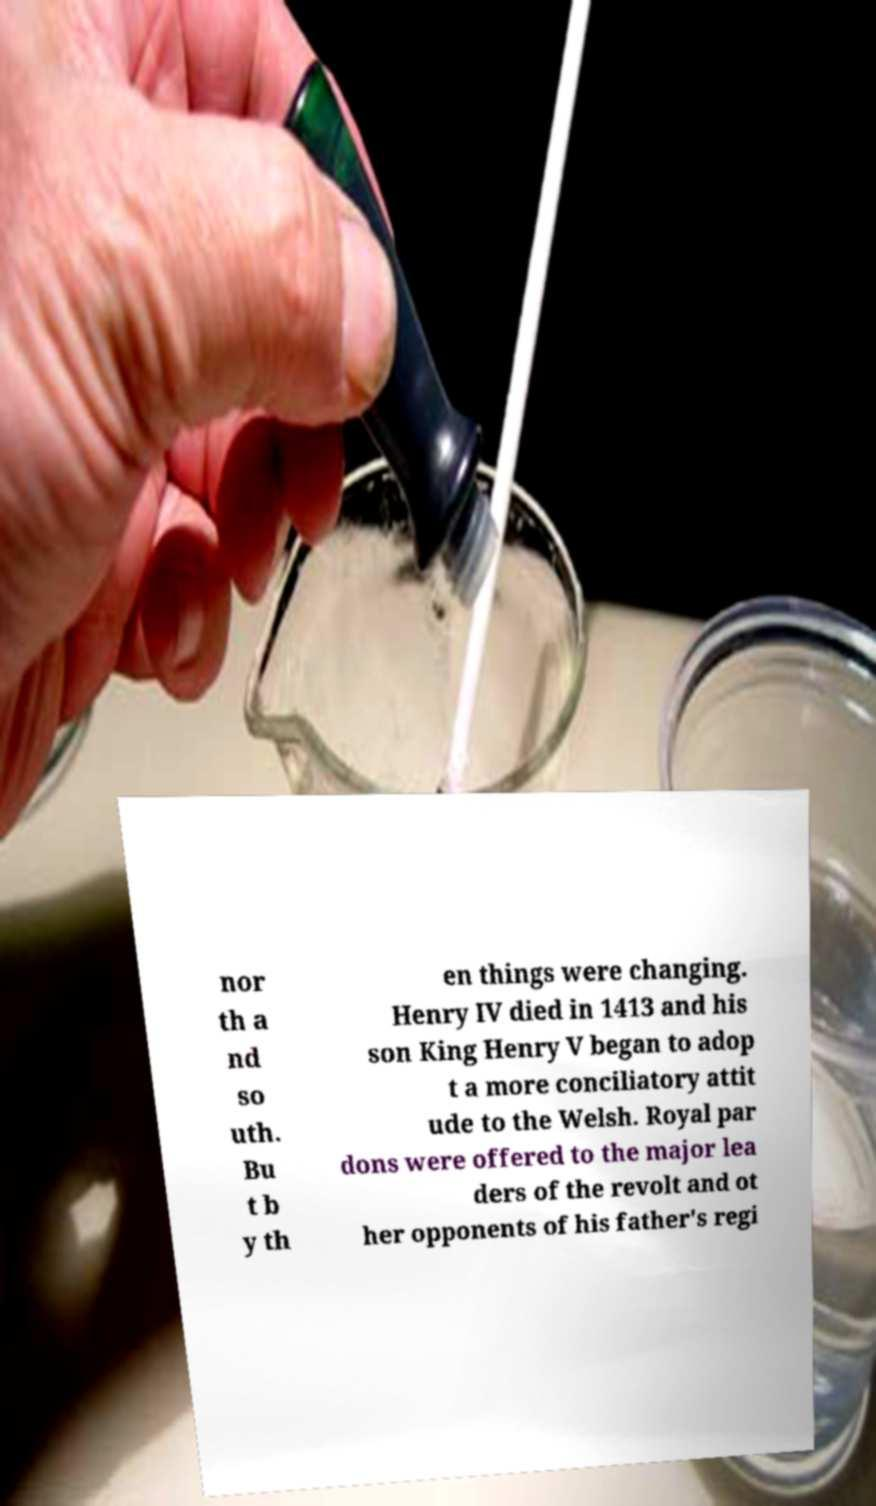What messages or text are displayed in this image? I need them in a readable, typed format. nor th a nd so uth. Bu t b y th en things were changing. Henry IV died in 1413 and his son King Henry V began to adop t a more conciliatory attit ude to the Welsh. Royal par dons were offered to the major lea ders of the revolt and ot her opponents of his father's regi 